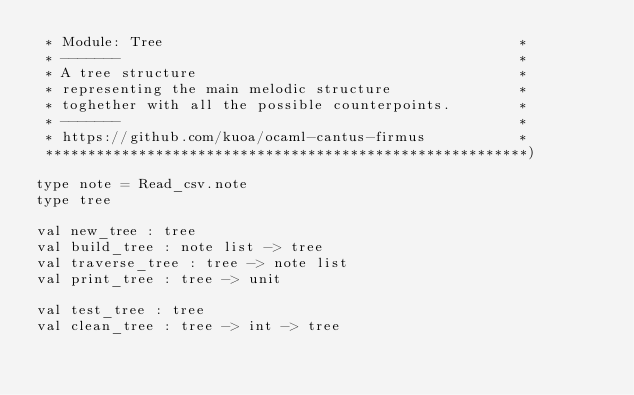<code> <loc_0><loc_0><loc_500><loc_500><_OCaml_> * Module: Tree                                          *
 * -------                                               *
 * A tree structure                                      * 
 * representing the main melodic structure               *
 * toghether with all the possible counterpoints.        * 
 * -------                                               *
 * https://github.com/kuoa/ocaml-cantus-firmus           *
 *********************************************************)

type note = Read_csv.note
type tree

val new_tree : tree		
val build_tree : note list -> tree
val traverse_tree : tree -> note list
val print_tree : tree -> unit

val test_tree : tree
val clean_tree : tree -> int -> tree

</code> 